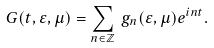<formula> <loc_0><loc_0><loc_500><loc_500>G ( t , \varepsilon , \mu ) = \sum _ { n \in { \mathbb { Z } } } \, g _ { n } ( \varepsilon , \mu ) e ^ { i n t } .</formula> 